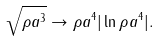Convert formula to latex. <formula><loc_0><loc_0><loc_500><loc_500>\sqrt { \rho a ^ { 3 } } \rightarrow \rho a ^ { 4 } | \ln \rho a ^ { 4 } | .</formula> 